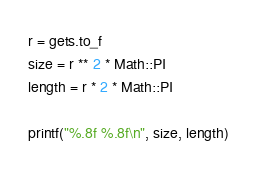<code> <loc_0><loc_0><loc_500><loc_500><_Ruby_>r = gets.to_f
size = r ** 2 * Math::PI
length = r * 2 * Math::PI

printf("%.8f %.8f\n", size, length)</code> 